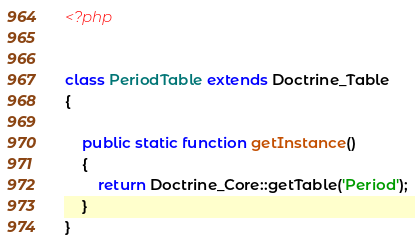<code> <loc_0><loc_0><loc_500><loc_500><_PHP_><?php


class PeriodTable extends Doctrine_Table
{
    
    public static function getInstance()
    {
        return Doctrine_Core::getTable('Period');
    }
}</code> 